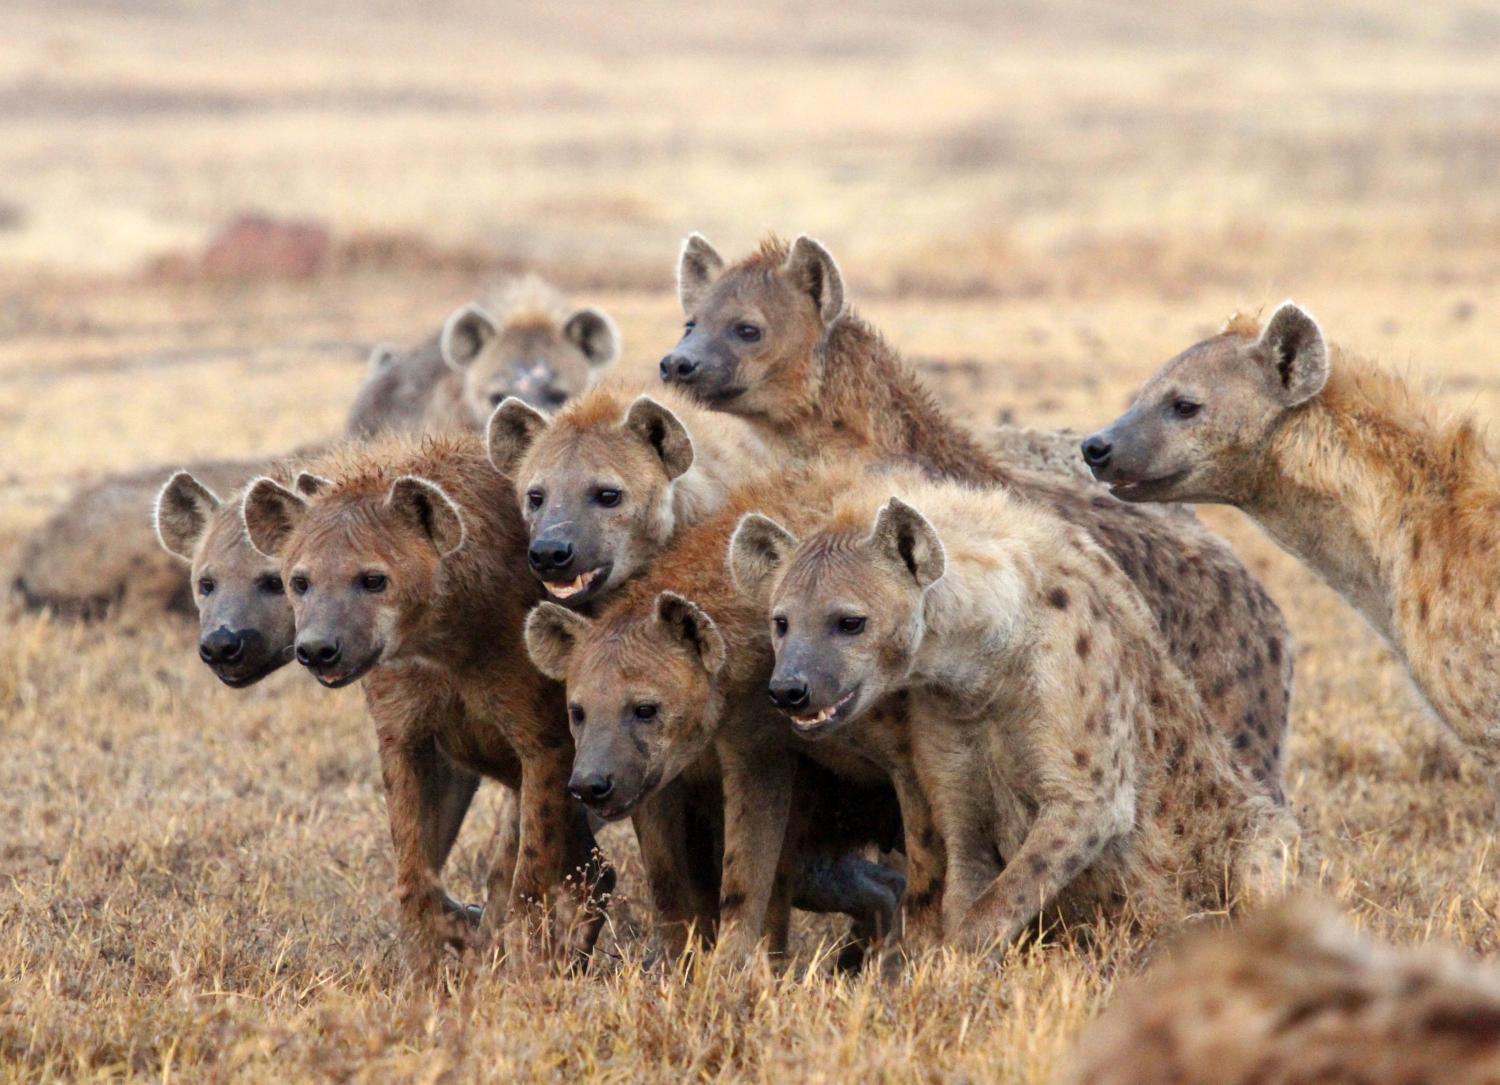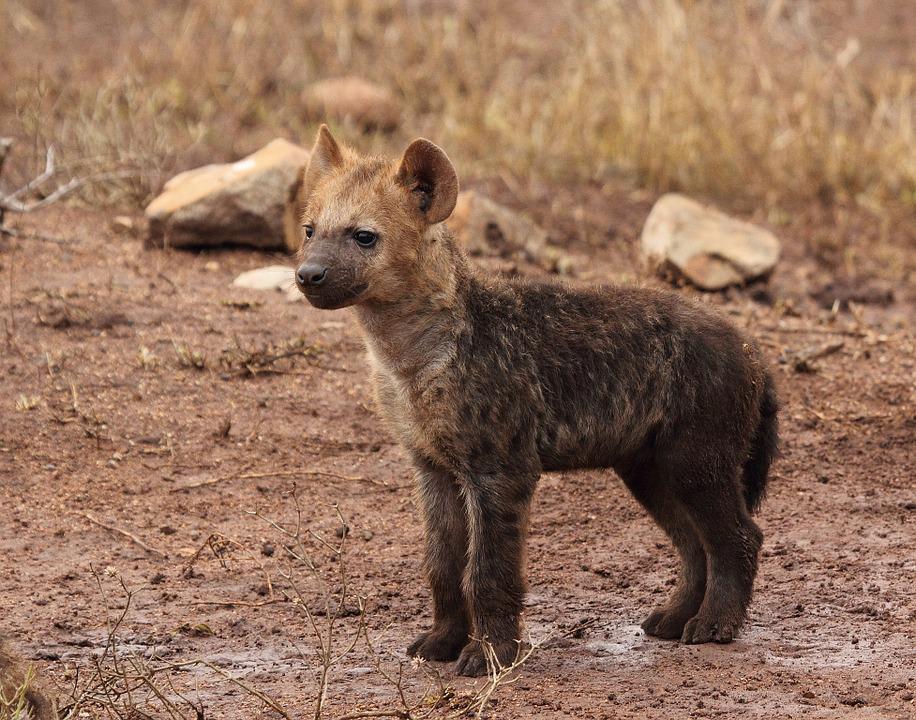The first image is the image on the left, the second image is the image on the right. Given the left and right images, does the statement "All of the images contain only one hyena." hold true? Answer yes or no. No. 